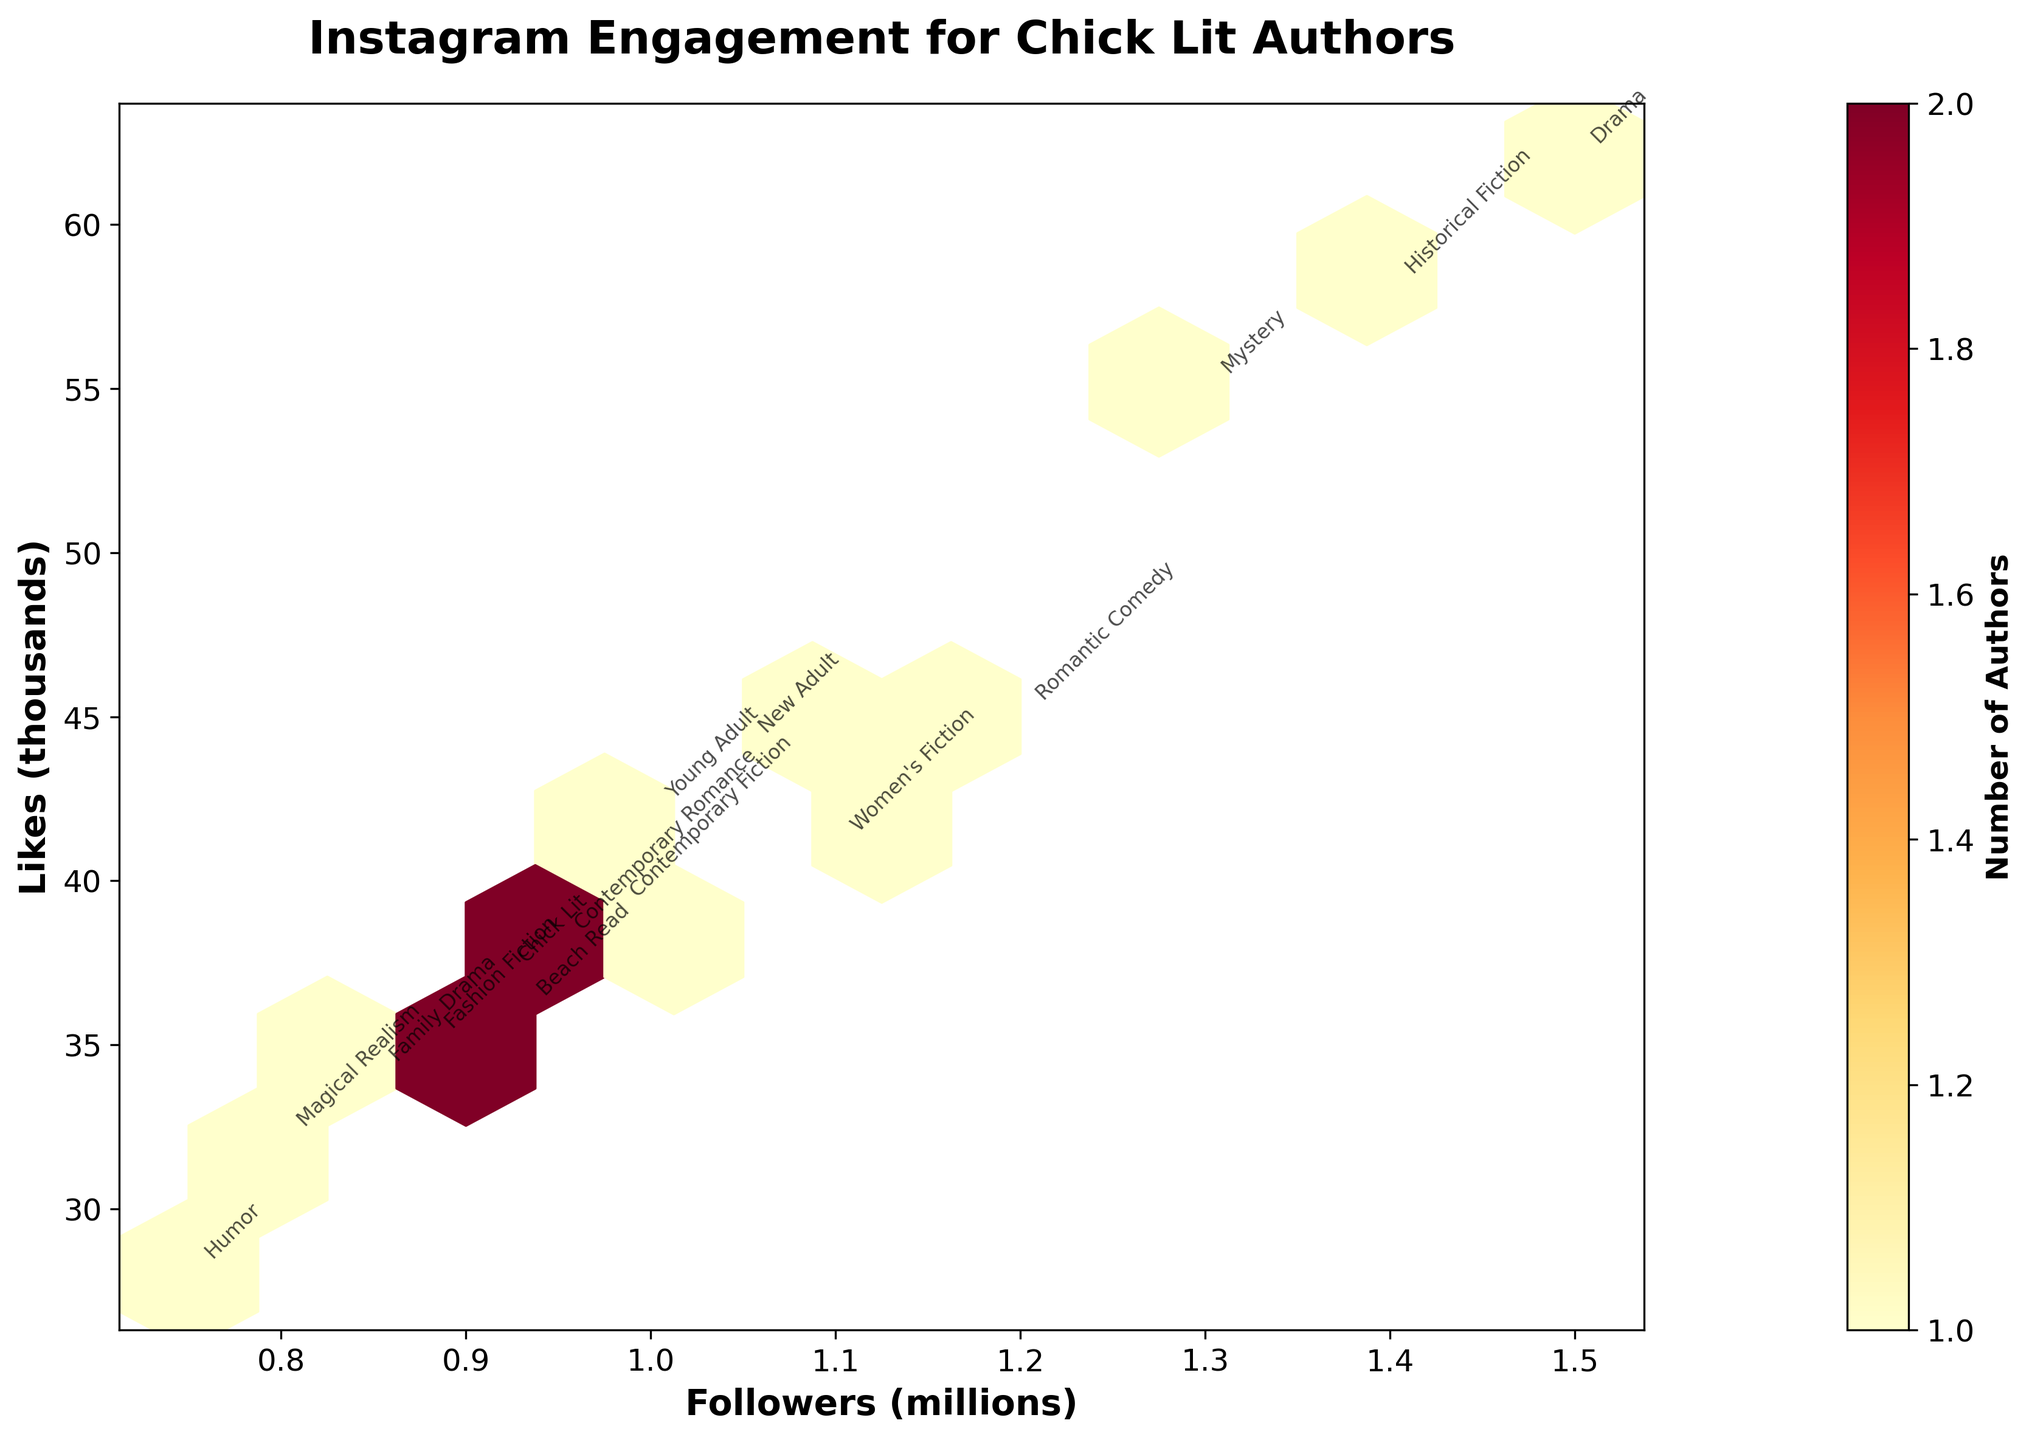What's the title of the hexbin plot? The title of the plot is located at the top of the figure, typically in a larger and bold font
Answer: Instagram Engagement for Chick Lit Authors How many authors fall in the highest-count hexbin cell? The highest-count hexbin cell can be identified by the darkest or most intense color within the hexbin plot and checked against the colorbar indicating the number of authors per intensity.
Answer: This will vary based on the plot, but typically the darkest color hexbin shows a higher count Which axis represents the number of followers? The axis representing the number of followers can be identified by looking at the label of the corresponding axis, which in this case is the horizontal axis labeled "Followers (millions)."
Answer: The horizontal axis Which genre appears at around 1.4 million followers and 58 thousand likes? To find this, look for the annotation text near the hexbin location corresponding to approximately 1.4 on the x-axis and 58 on the y-axis.
Answer: Historical Fiction Do authors with more followers generally receive more likes? By analyzing the trend in the hexbin plot, if the density of the cells increases in the direction of both higher followers and higher likes, then it suggests a general positive correlation.
Answer: Yes Which genre has the closest annotation to 0.75 million followers and 28 thousand likes? Find the annotation text near the plot point closest to 0.75 on the x-axis and 28 on the y-axis, looking at the hexbin and annotation labels.
Answer: Humor What is the range of followers in millions covered by the hexbin plot? The ranges can be observed by looking at the lower and upper limits of the x-axis labels, from the minimum to the maximum marked value.
Answer: 0.75 to 1.5 million Which two genres are closely clustered with annotations around 1 million followers and 40 thousand likes? Look near the hexbin cells around 1 million on the x-axis and 40 thousand on the y-axis to identify the closely placed annotations.
Answer: Women's Fiction and New Adult How many authors have between 1.2 million and 1.5 million followers and over 55 thousand likes? By observing hexbin cells within this range of the x-axis and y-axis and checking the associated color intensity related to the number of authors from the colorbar.
Answer: This count will depend on the plot specifics, refer to the color and density within this range Which axis indicates the number of likes in the plot? The label on the y-axis indicates the number of likes, which in this case is the vertical axis labeled "Likes (thousands)."
Answer: The vertical axis 